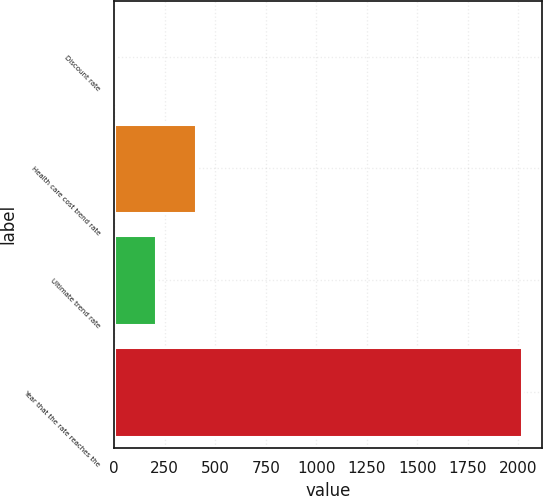Convert chart. <chart><loc_0><loc_0><loc_500><loc_500><bar_chart><fcel>Discount rate<fcel>Health care cost trend rate<fcel>Ultimate trend rate<fcel>Year that the rate reaches the<nl><fcel>3.9<fcel>406.72<fcel>205.31<fcel>2018<nl></chart> 